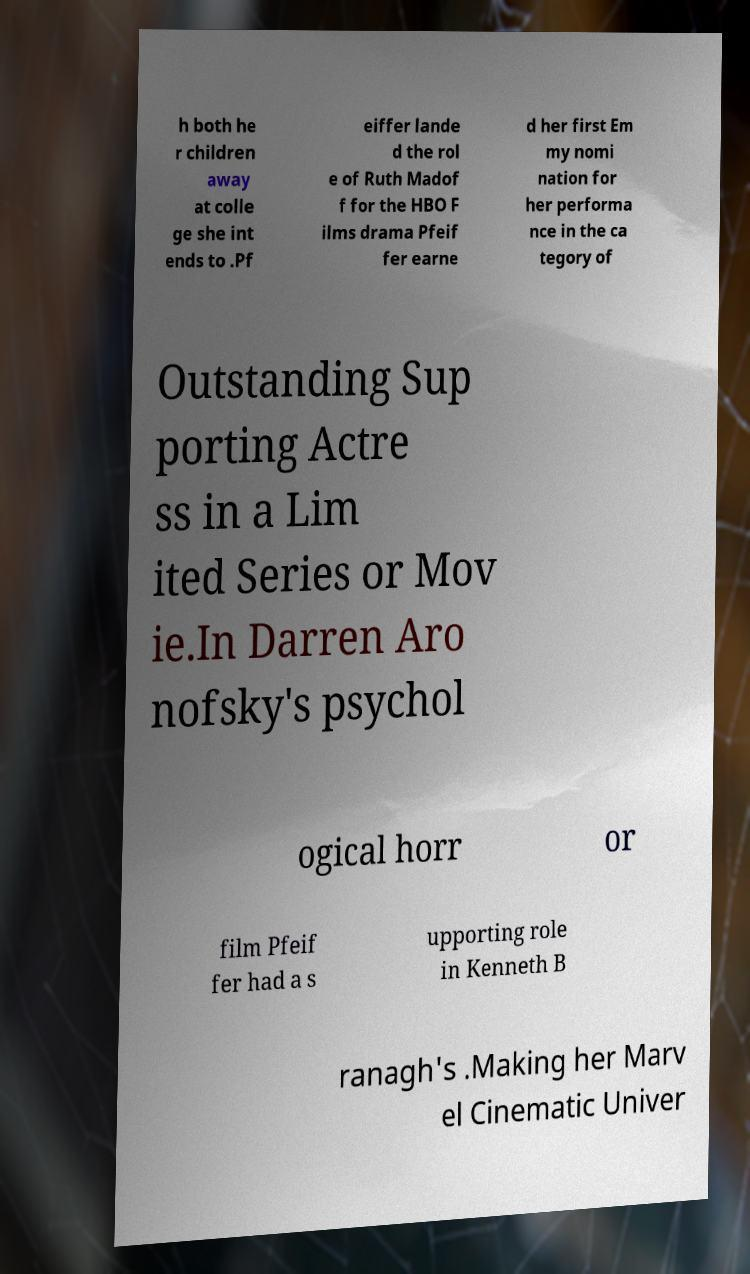There's text embedded in this image that I need extracted. Can you transcribe it verbatim? h both he r children away at colle ge she int ends to .Pf eiffer lande d the rol e of Ruth Madof f for the HBO F ilms drama Pfeif fer earne d her first Em my nomi nation for her performa nce in the ca tegory of Outstanding Sup porting Actre ss in a Lim ited Series or Mov ie.In Darren Aro nofsky's psychol ogical horr or film Pfeif fer had a s upporting role in Kenneth B ranagh's .Making her Marv el Cinematic Univer 